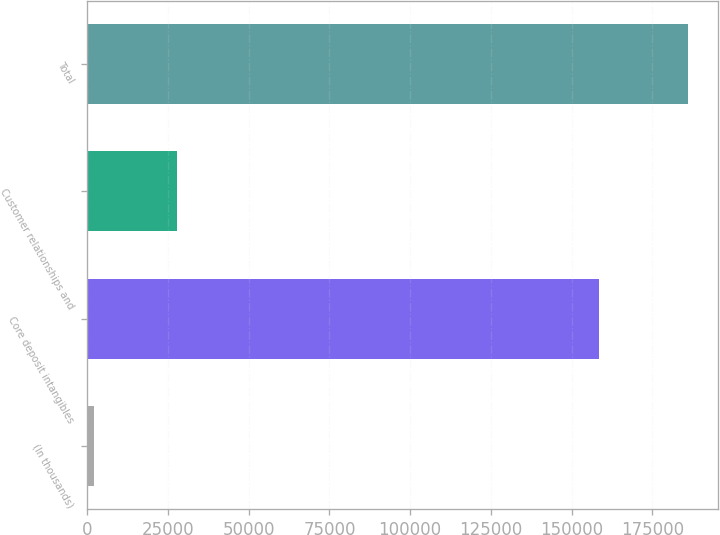Convert chart to OTSL. <chart><loc_0><loc_0><loc_500><loc_500><bar_chart><fcel>(In thousands)<fcel>Core deposit intangibles<fcel>Customer relationships and<fcel>Total<nl><fcel>2016<fcel>158444<fcel>27668<fcel>186112<nl></chart> 